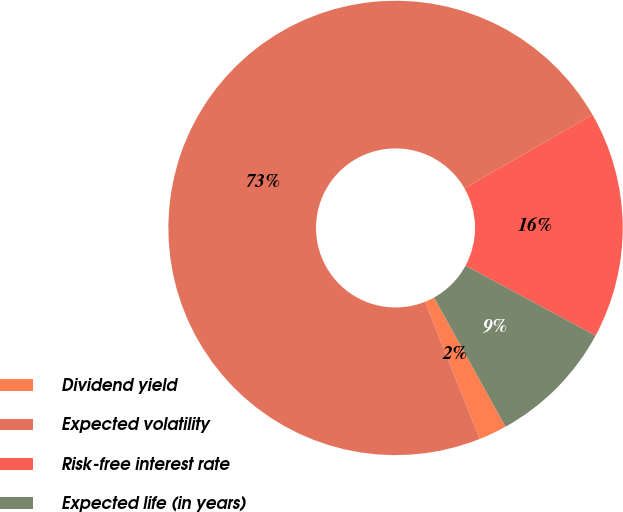Convert chart. <chart><loc_0><loc_0><loc_500><loc_500><pie_chart><fcel>Dividend yield<fcel>Expected volatility<fcel>Risk-free interest rate<fcel>Expected life (in years)<nl><fcel>2.0%<fcel>72.74%<fcel>16.17%<fcel>9.09%<nl></chart> 